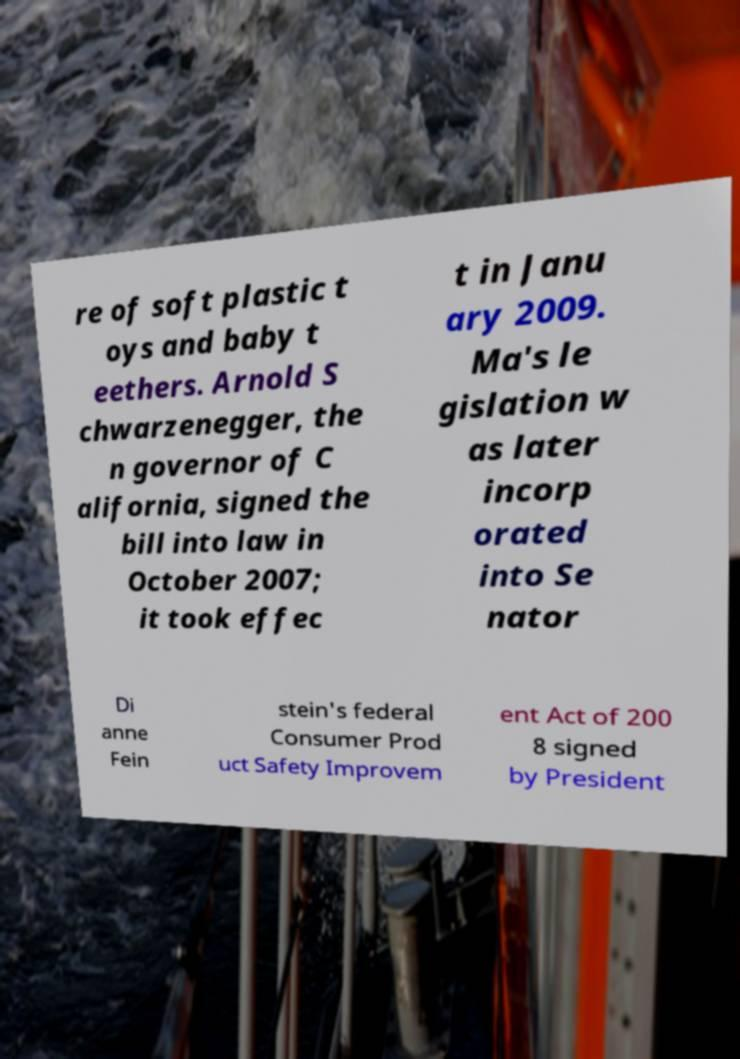Could you extract and type out the text from this image? re of soft plastic t oys and baby t eethers. Arnold S chwarzenegger, the n governor of C alifornia, signed the bill into law in October 2007; it took effec t in Janu ary 2009. Ma's le gislation w as later incorp orated into Se nator Di anne Fein stein's federal Consumer Prod uct Safety Improvem ent Act of 200 8 signed by President 